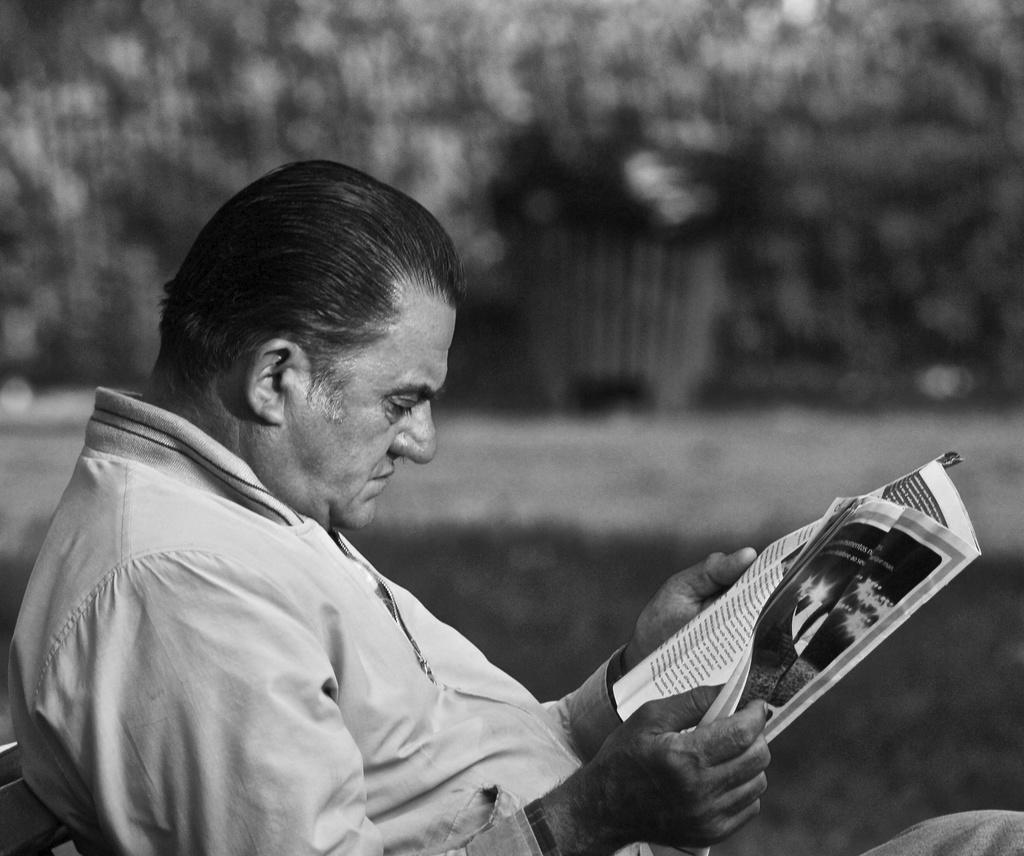What is the main subject of the black and white picture in the image? The main subject of the black and white picture is a man sitting. What can be observed about the man's attire in the image? The man is wearing clothes in the image. What is the man holding in his hands in the image? The man is holding a paper in his hands in the image. How would you describe the background of the image? The background of the image is blurred. What is the value of the drain in the image? There is no drain present in the image, so it is not possible to determine its value. 